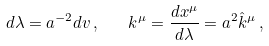<formula> <loc_0><loc_0><loc_500><loc_500>d \lambda = a ^ { - 2 } d v \, , \quad k ^ { \mu } = \frac { d x ^ { \mu } } { d \lambda } = a ^ { 2 } \hat { k } ^ { \mu } \, ,</formula> 